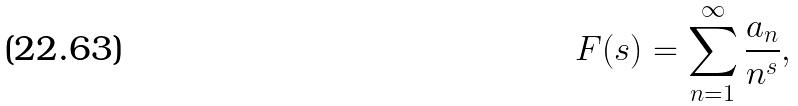<formula> <loc_0><loc_0><loc_500><loc_500>F ( s ) = \sum _ { n = 1 } ^ { \infty } \frac { a _ { n } } { n ^ { s } } ,</formula> 